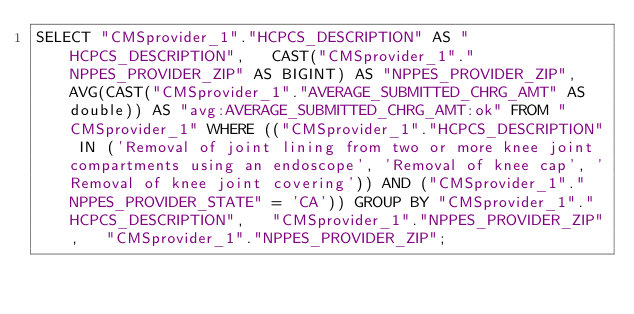<code> <loc_0><loc_0><loc_500><loc_500><_SQL_>SELECT "CMSprovider_1"."HCPCS_DESCRIPTION" AS "HCPCS_DESCRIPTION",   CAST("CMSprovider_1"."NPPES_PROVIDER_ZIP" AS BIGINT) AS "NPPES_PROVIDER_ZIP",   AVG(CAST("CMSprovider_1"."AVERAGE_SUBMITTED_CHRG_AMT" AS double)) AS "avg:AVERAGE_SUBMITTED_CHRG_AMT:ok" FROM "CMSprovider_1" WHERE (("CMSprovider_1"."HCPCS_DESCRIPTION" IN ('Removal of joint lining from two or more knee joint compartments using an endoscope', 'Removal of knee cap', 'Removal of knee joint covering')) AND ("CMSprovider_1"."NPPES_PROVIDER_STATE" = 'CA')) GROUP BY "CMSprovider_1"."HCPCS_DESCRIPTION",   "CMSprovider_1"."NPPES_PROVIDER_ZIP",   "CMSprovider_1"."NPPES_PROVIDER_ZIP";
</code> 